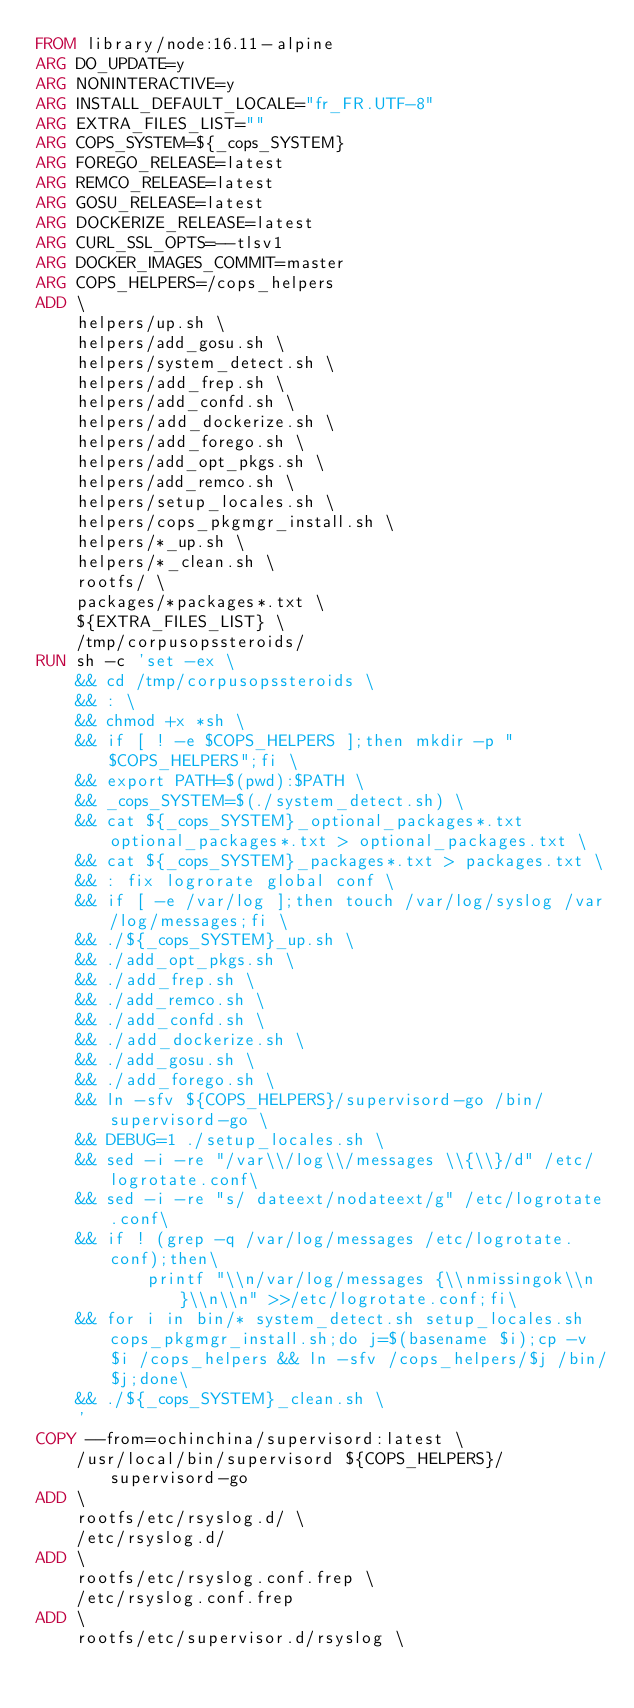Convert code to text. <code><loc_0><loc_0><loc_500><loc_500><_Dockerfile_>FROM library/node:16.11-alpine
ARG DO_UPDATE=y
ARG NONINTERACTIVE=y
ARG INSTALL_DEFAULT_LOCALE="fr_FR.UTF-8"
ARG EXTRA_FILES_LIST=""
ARG COPS_SYSTEM=${_cops_SYSTEM}
ARG FOREGO_RELEASE=latest
ARG REMCO_RELEASE=latest
ARG GOSU_RELEASE=latest
ARG DOCKERIZE_RELEASE=latest
ARG CURL_SSL_OPTS=--tlsv1
ARG DOCKER_IMAGES_COMMIT=master
ARG COPS_HELPERS=/cops_helpers
ADD \
    helpers/up.sh \
    helpers/add_gosu.sh \
    helpers/system_detect.sh \
    helpers/add_frep.sh \
    helpers/add_confd.sh \
    helpers/add_dockerize.sh \
    helpers/add_forego.sh \
    helpers/add_opt_pkgs.sh \
    helpers/add_remco.sh \
    helpers/setup_locales.sh \
    helpers/cops_pkgmgr_install.sh \
    helpers/*_up.sh \
    helpers/*_clean.sh \
    rootfs/ \
    packages/*packages*.txt \
    ${EXTRA_FILES_LIST} \
    /tmp/corpusopssteroids/
RUN sh -c 'set -ex \
    && cd /tmp/corpusopssteroids \
    && : \
    && chmod +x *sh \
    && if [ ! -e $COPS_HELPERS ];then mkdir -p "$COPS_HELPERS";fi \
    && export PATH=$(pwd):$PATH \
    && _cops_SYSTEM=$(./system_detect.sh) \
    && cat ${_cops_SYSTEM}_optional_packages*.txt optional_packages*.txt > optional_packages.txt \
    && cat ${_cops_SYSTEM}_packages*.txt > packages.txt \
    && : fix logrorate global conf \
    && if [ -e /var/log ];then touch /var/log/syslog /var/log/messages;fi \
    && ./${_cops_SYSTEM}_up.sh \
    && ./add_opt_pkgs.sh \
    && ./add_frep.sh \
    && ./add_remco.sh \
    && ./add_confd.sh \
    && ./add_dockerize.sh \
    && ./add_gosu.sh \
    && ./add_forego.sh \
    && ln -sfv ${COPS_HELPERS}/supervisord-go /bin/supervisord-go \
    && DEBUG=1 ./setup_locales.sh \
    && sed -i -re "/var\\/log\\/messages \\{\\}/d" /etc/logrotate.conf\
    && sed -i -re "s/ dateext/nodateext/g" /etc/logrotate.conf\
    && if ! (grep -q /var/log/messages /etc/logrotate.conf);then\
           printf "\\n/var/log/messages {\\nmissingok\\n}\\n\\n" >>/etc/logrotate.conf;fi\
    && for i in bin/* system_detect.sh setup_locales.sh cops_pkgmgr_install.sh;do j=$(basename $i);cp -v $i /cops_helpers && ln -sfv /cops_helpers/$j /bin/$j;done\
    && ./${_cops_SYSTEM}_clean.sh \
    '
COPY --from=ochinchina/supervisord:latest \
    /usr/local/bin/supervisord ${COPS_HELPERS}/supervisord-go
ADD \
    rootfs/etc/rsyslog.d/ \
    /etc/rsyslog.d/
ADD \
    rootfs/etc/rsyslog.conf.frep \
    /etc/rsyslog.conf.frep
ADD \
    rootfs/etc/supervisor.d/rsyslog \</code> 